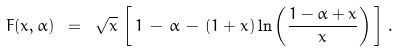Convert formula to latex. <formula><loc_0><loc_0><loc_500><loc_500>F ( x , \alpha ) \ = \ \sqrt { x } \, \left [ \, 1 \, - \, \alpha \, - \, ( 1 + x ) \ln \left ( \frac { 1 - \alpha + x } { x } \right ) \, \right ] \, .</formula> 